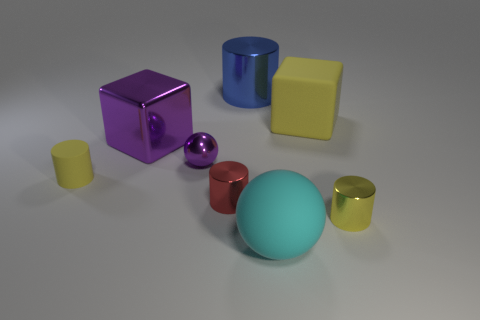Are there the same number of small yellow cylinders that are behind the red shiny thing and tiny rubber things that are in front of the small yellow metallic thing?
Offer a terse response. No. What color is the cylinder that is right of the small red thing and left of the big sphere?
Ensure brevity in your answer.  Blue. What material is the object that is behind the rubber thing that is right of the cyan sphere?
Provide a succinct answer. Metal. Do the metallic sphere and the cyan thing have the same size?
Your answer should be very brief. No. What number of small things are either cyan matte objects or brown matte cubes?
Your answer should be compact. 0. How many purple blocks are in front of the tiny shiny ball?
Offer a very short reply. 0. Is the number of yellow rubber things that are on the right side of the big cyan object greater than the number of small red metallic balls?
Give a very brief answer. Yes. There is a yellow object that is the same material as the small red thing; what is its shape?
Offer a very short reply. Cylinder. What is the color of the matte thing that is in front of the tiny yellow object that is in front of the small red metal cylinder?
Your answer should be very brief. Cyan. Is the tiny purple object the same shape as the large cyan thing?
Ensure brevity in your answer.  Yes. 